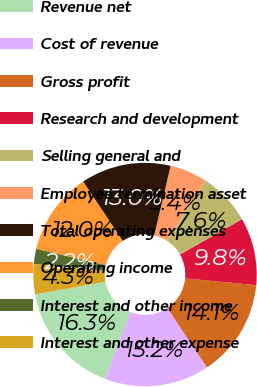Convert chart to OTSL. <chart><loc_0><loc_0><loc_500><loc_500><pie_chart><fcel>Revenue net<fcel>Cost of revenue<fcel>Gross profit<fcel>Research and development<fcel>Selling general and<fcel>Employee termination asset<fcel>Total operating expenses<fcel>Operating income<fcel>Interest and other income<fcel>Interest and other expense<nl><fcel>16.3%<fcel>15.21%<fcel>14.13%<fcel>9.78%<fcel>7.61%<fcel>5.44%<fcel>13.04%<fcel>11.96%<fcel>2.18%<fcel>4.35%<nl></chart> 